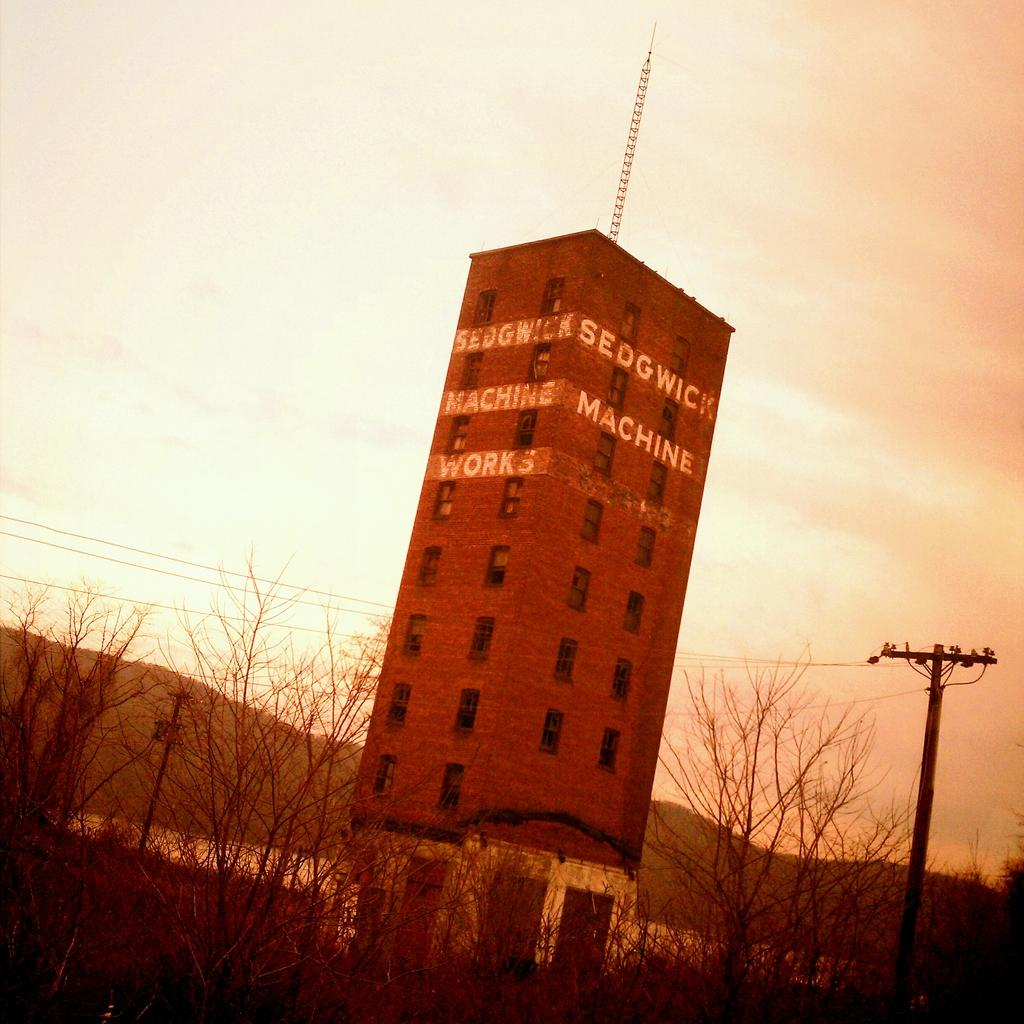What is the main structure in the middle of the image? There is a brown color tower in the middle of the image. What can be seen at the front bottom side of the image? There are dry trees and an electric pole with cable in the front bottom side of the image. What page of the book is the star mentioned on? There is no book or star present in the image, so this question cannot be answered. 